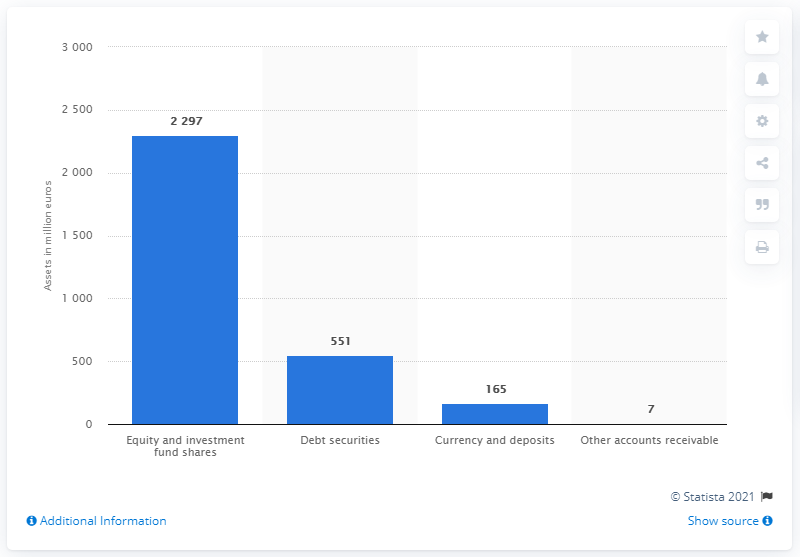Specify some key components in this picture. In 2019, the total value of financial assets held by investment funds in debt securities in Slovenia was approximately 551. In 2019, the value of equity and investment fund shares in Slovenia was approximately 2297. 